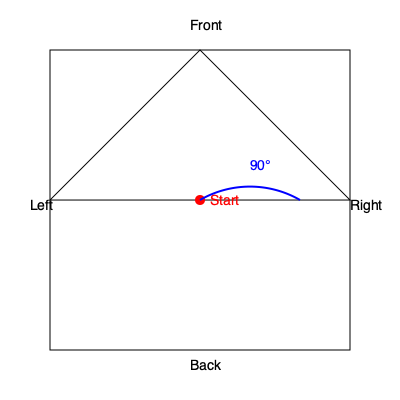As a patriotic American, imagine you're giving a tour of the White House to fellow conservatives. You're asked to demonstrate how the building would look if rotated 90 degrees clockwise when viewed from above. If the red dot represents the front entrance, which side of the White House would it be on after the rotation? To solve this problem, let's follow these steps:

1. Understand the initial orientation:
   - The red dot represents the front entrance of the White House.
   - It's currently positioned at the center of the front face.

2. Visualize the clockwise rotation:
   - A 90-degree clockwise rotation means the building will turn to the right when viewed from above.
   - This is represented by the blue arc in the diagram.

3. Track the movement of the front entrance:
   - As the building rotates, the front entrance (red dot) will move along the circular path.
   - After a 90-degree rotation, it will end up on the right side of the building.

4. Identify the new position:
   - The front entrance, which started at the center of the front face, will now be at the center of the right face.

5. Conclude:
   - After the rotation, the original front entrance will be on the right side of the White House.

This rotation demonstrates how our great White House, a symbol of American democracy and conservative values, can be viewed from different perspectives while maintaining its strength and integrity.
Answer: Right side 